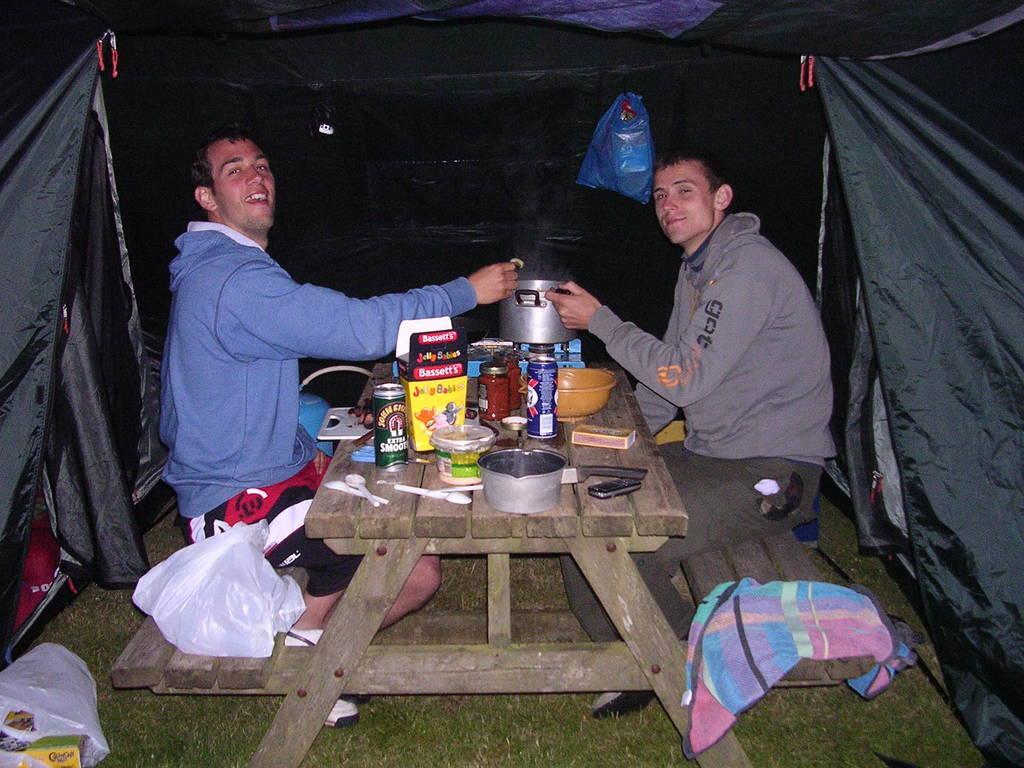Describe this image in one or two sentences. As we can see in the image, there are two people sitting on benches and on the bench there is a stove, bowl, box, glasses, match box, mobile phone and spoons and there is a white color cover over here. 